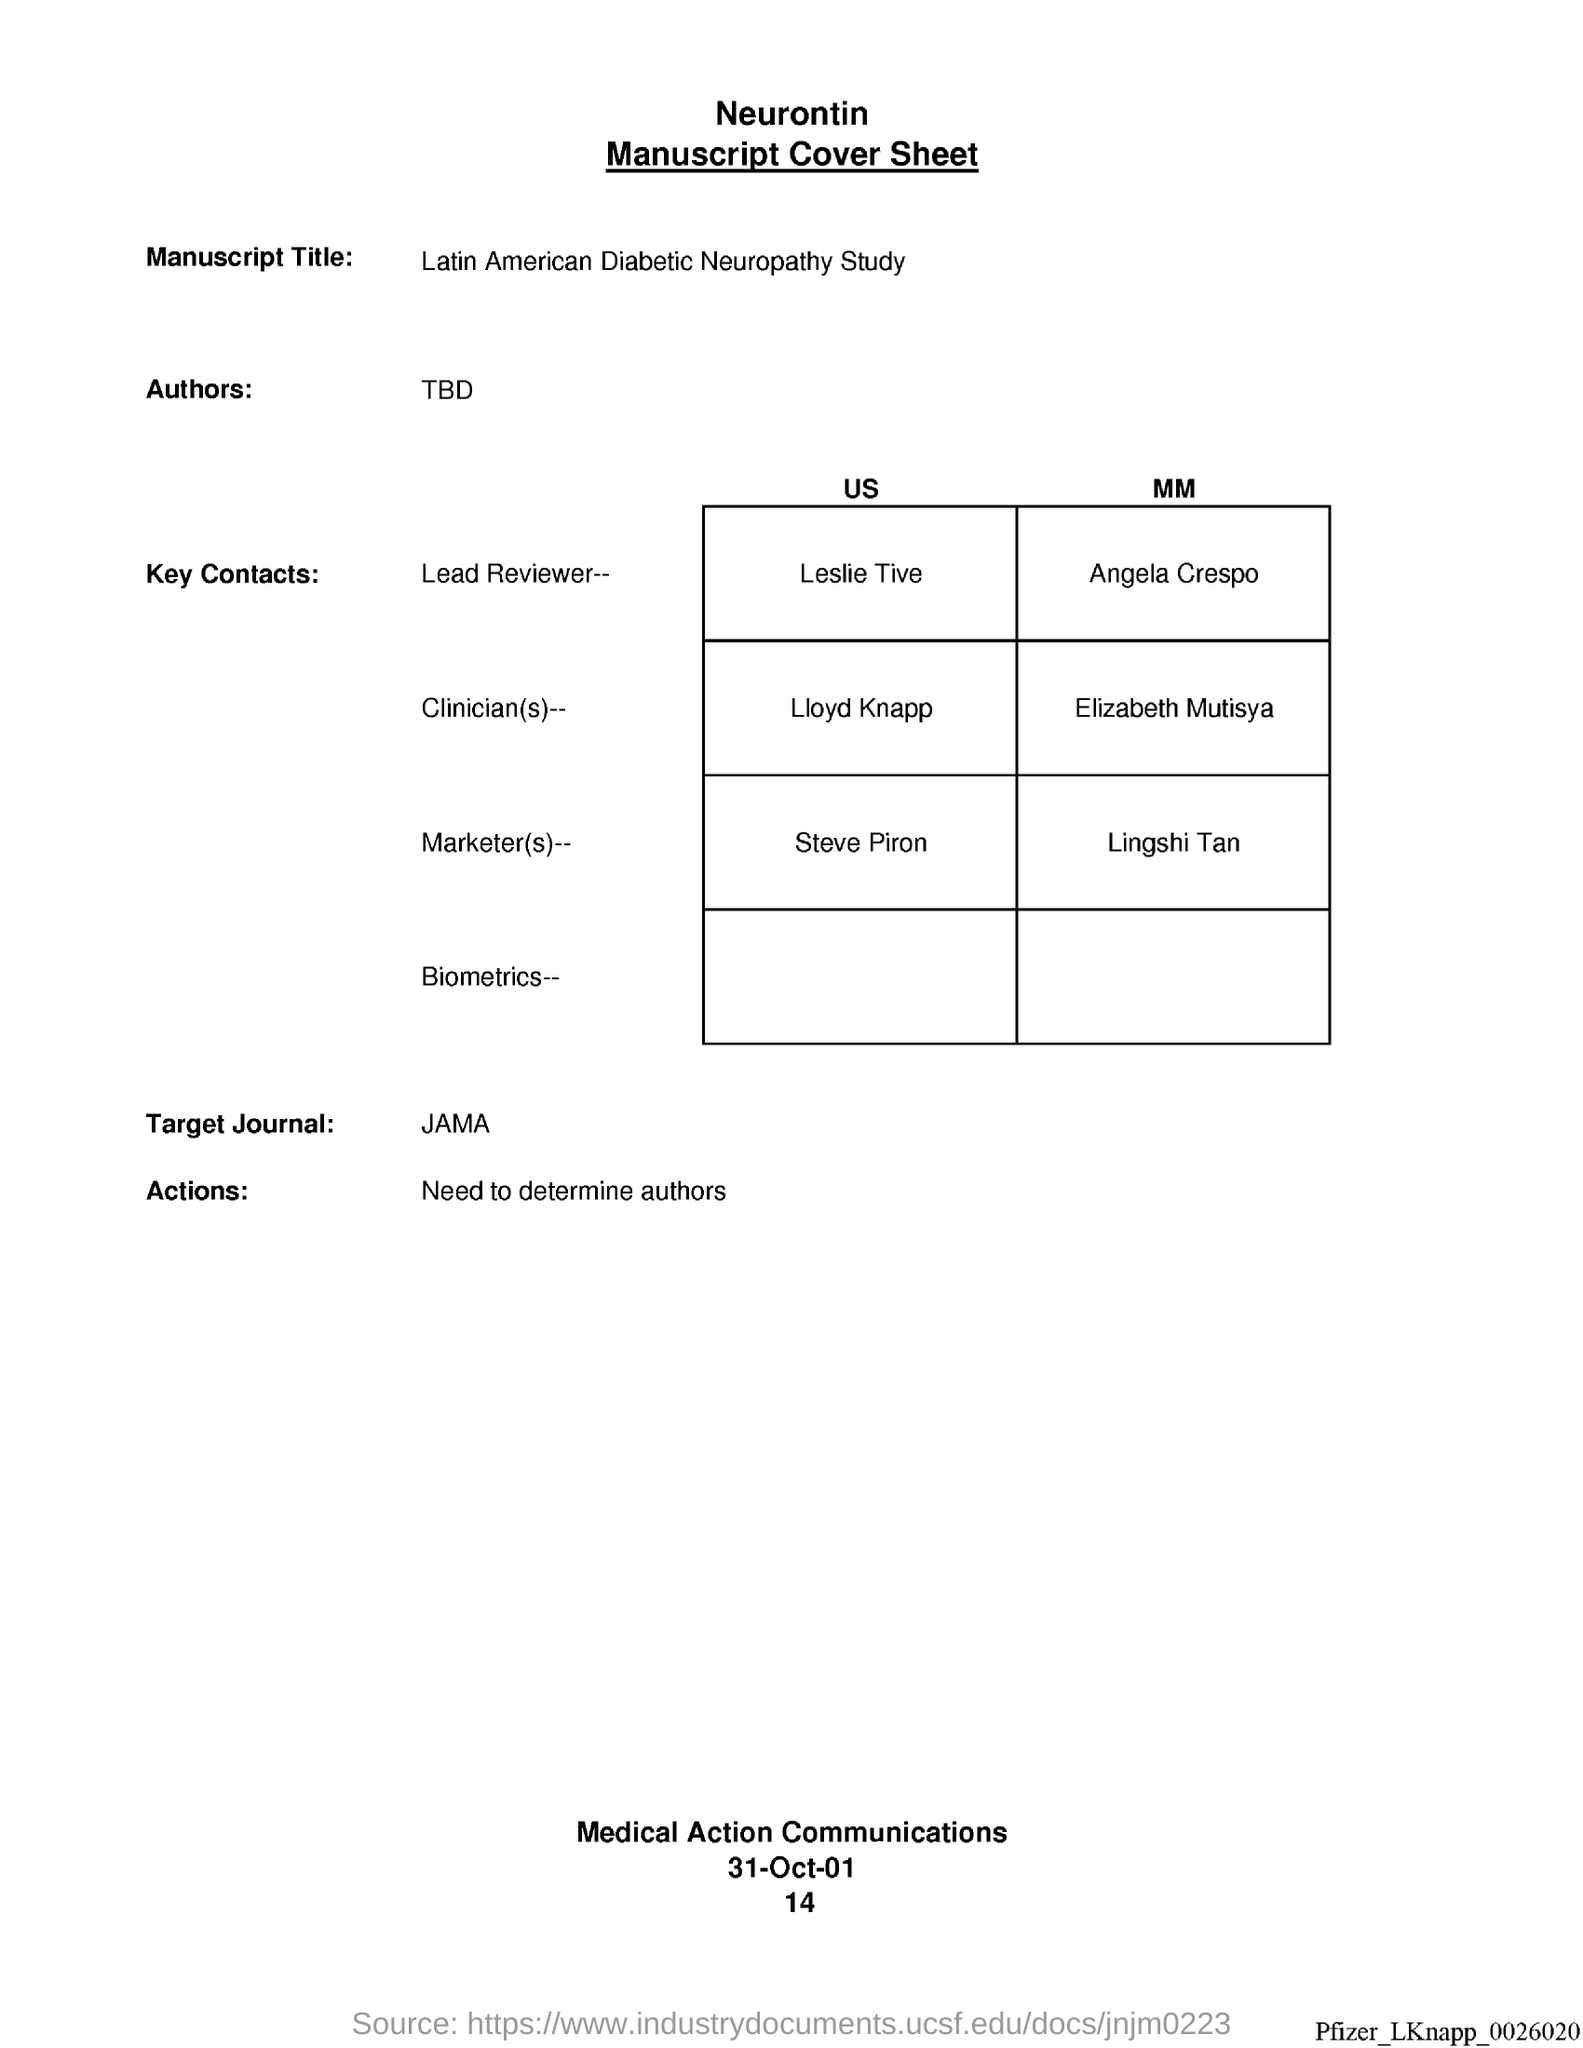What is the manuscript title ?
Offer a terse response. Latin American Diabetic Neuropathy study. Who is the lead reviewer, us?
Offer a very short reply. Leslie Tive. Who is lead reviewer, mm?
Provide a short and direct response. Angela crespo. Who is the clinician (s), us ?
Provide a short and direct response. Lloyd knapp. Who is the clinician (s), mm?
Offer a terse response. Elizabeth Mutisya. Who is the marketer(s), us?
Your answer should be very brief. Steve piron. Who is the market(s), mm?
Give a very brief answer. Lingshi tan. What is the target journal?
Your answer should be very brief. JAMA. What is the date at bottom of the page?
Ensure brevity in your answer.  31-oct-01. What is the page number below date?
Ensure brevity in your answer.  14. 